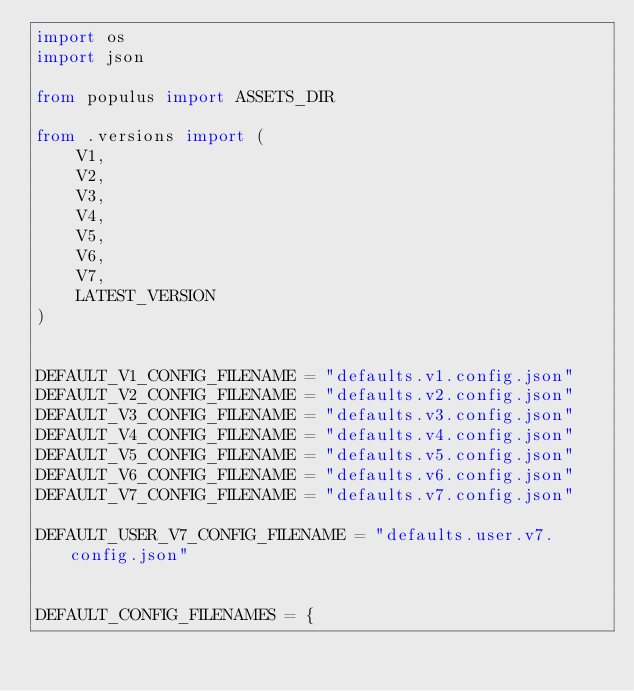<code> <loc_0><loc_0><loc_500><loc_500><_Python_>import os
import json

from populus import ASSETS_DIR

from .versions import (
    V1,
    V2,
    V3,
    V4,
    V5,
    V6,
    V7,
    LATEST_VERSION
)


DEFAULT_V1_CONFIG_FILENAME = "defaults.v1.config.json"
DEFAULT_V2_CONFIG_FILENAME = "defaults.v2.config.json"
DEFAULT_V3_CONFIG_FILENAME = "defaults.v3.config.json"
DEFAULT_V4_CONFIG_FILENAME = "defaults.v4.config.json"
DEFAULT_V5_CONFIG_FILENAME = "defaults.v5.config.json"
DEFAULT_V6_CONFIG_FILENAME = "defaults.v6.config.json"
DEFAULT_V7_CONFIG_FILENAME = "defaults.v7.config.json"

DEFAULT_USER_V7_CONFIG_FILENAME = "defaults.user.v7.config.json"


DEFAULT_CONFIG_FILENAMES = {</code> 